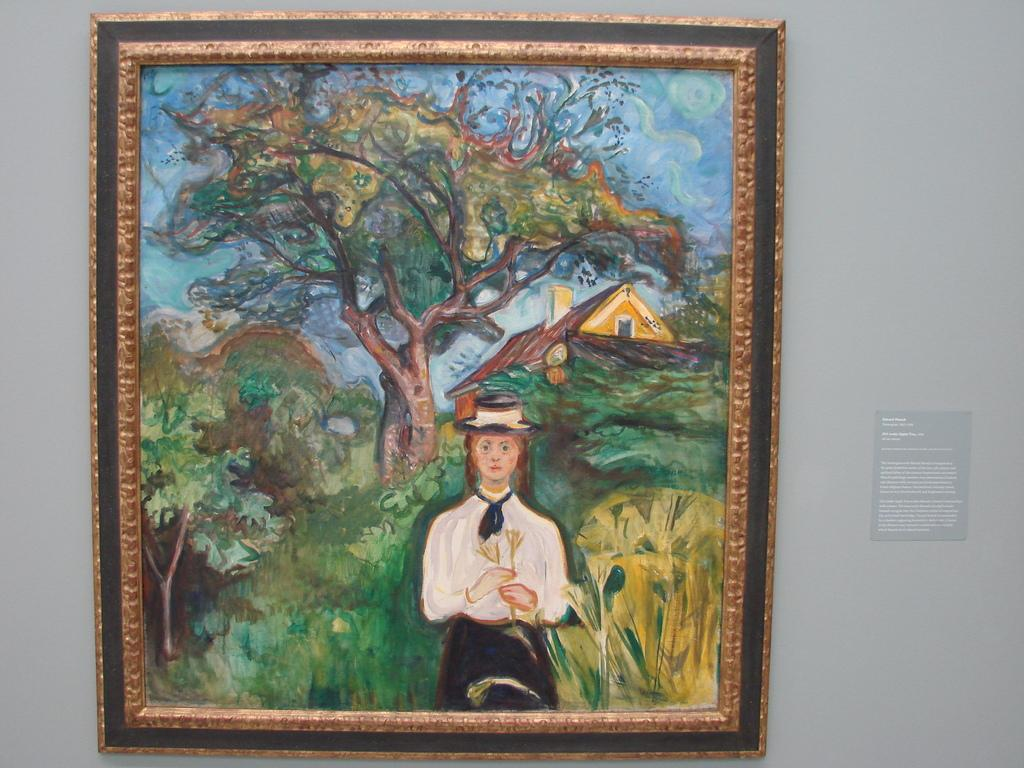What is present on the wall in the image? There is a painting on the wall. What elements are included in the painting? The painting contains a person, a house, a tree, and sky. What is on the right side of the wall? There is a paper pasted on the right side of the wall. What color is the sweater worn by the person in the painting? There is no sweater mentioned or visible in the painting; it only contains a person, a house, a tree, and sky. How does the ball affect the painting's composition? There is no ball present in the painting or the image. 